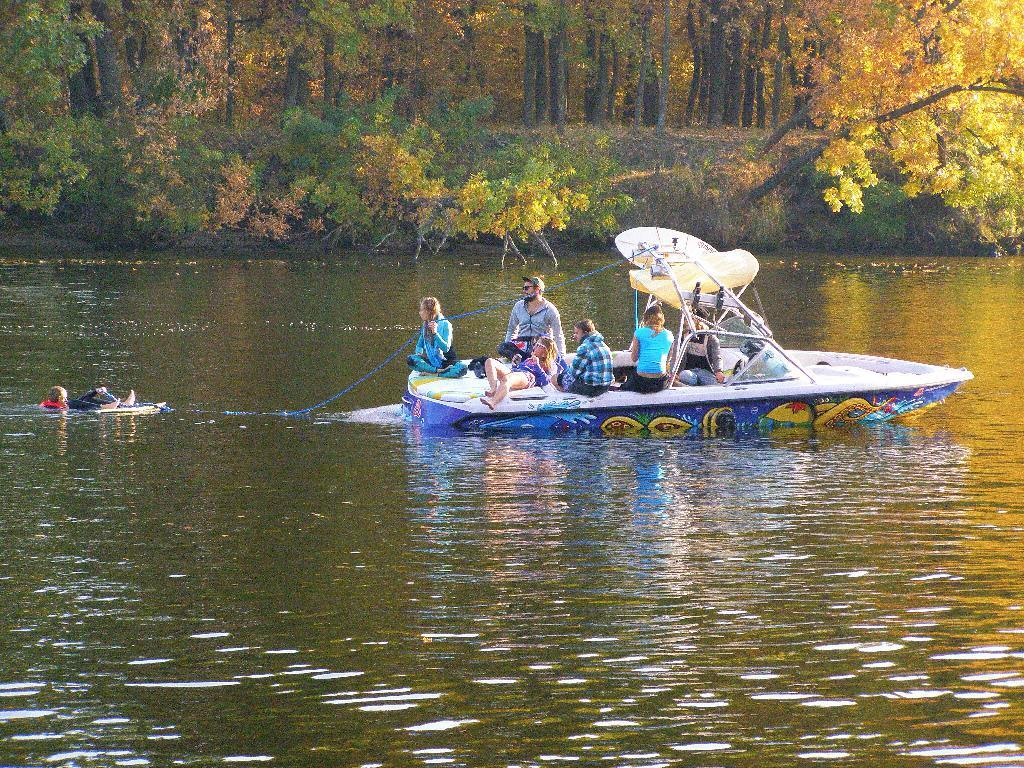What is the main subject in the center of the image? There is a boat in the center of the image with persons sitting on it. Can you describe the activity of the person on the left side of the image? There is a person sleeping on a boat on the left side of the image. What can be seen in the background of the image? There are trees in the background of the image. What unit of measurement is used to determine the distance between the two boats in the image? There is only one boat visible in the image, so there is no need to measure the distance between two boats. 